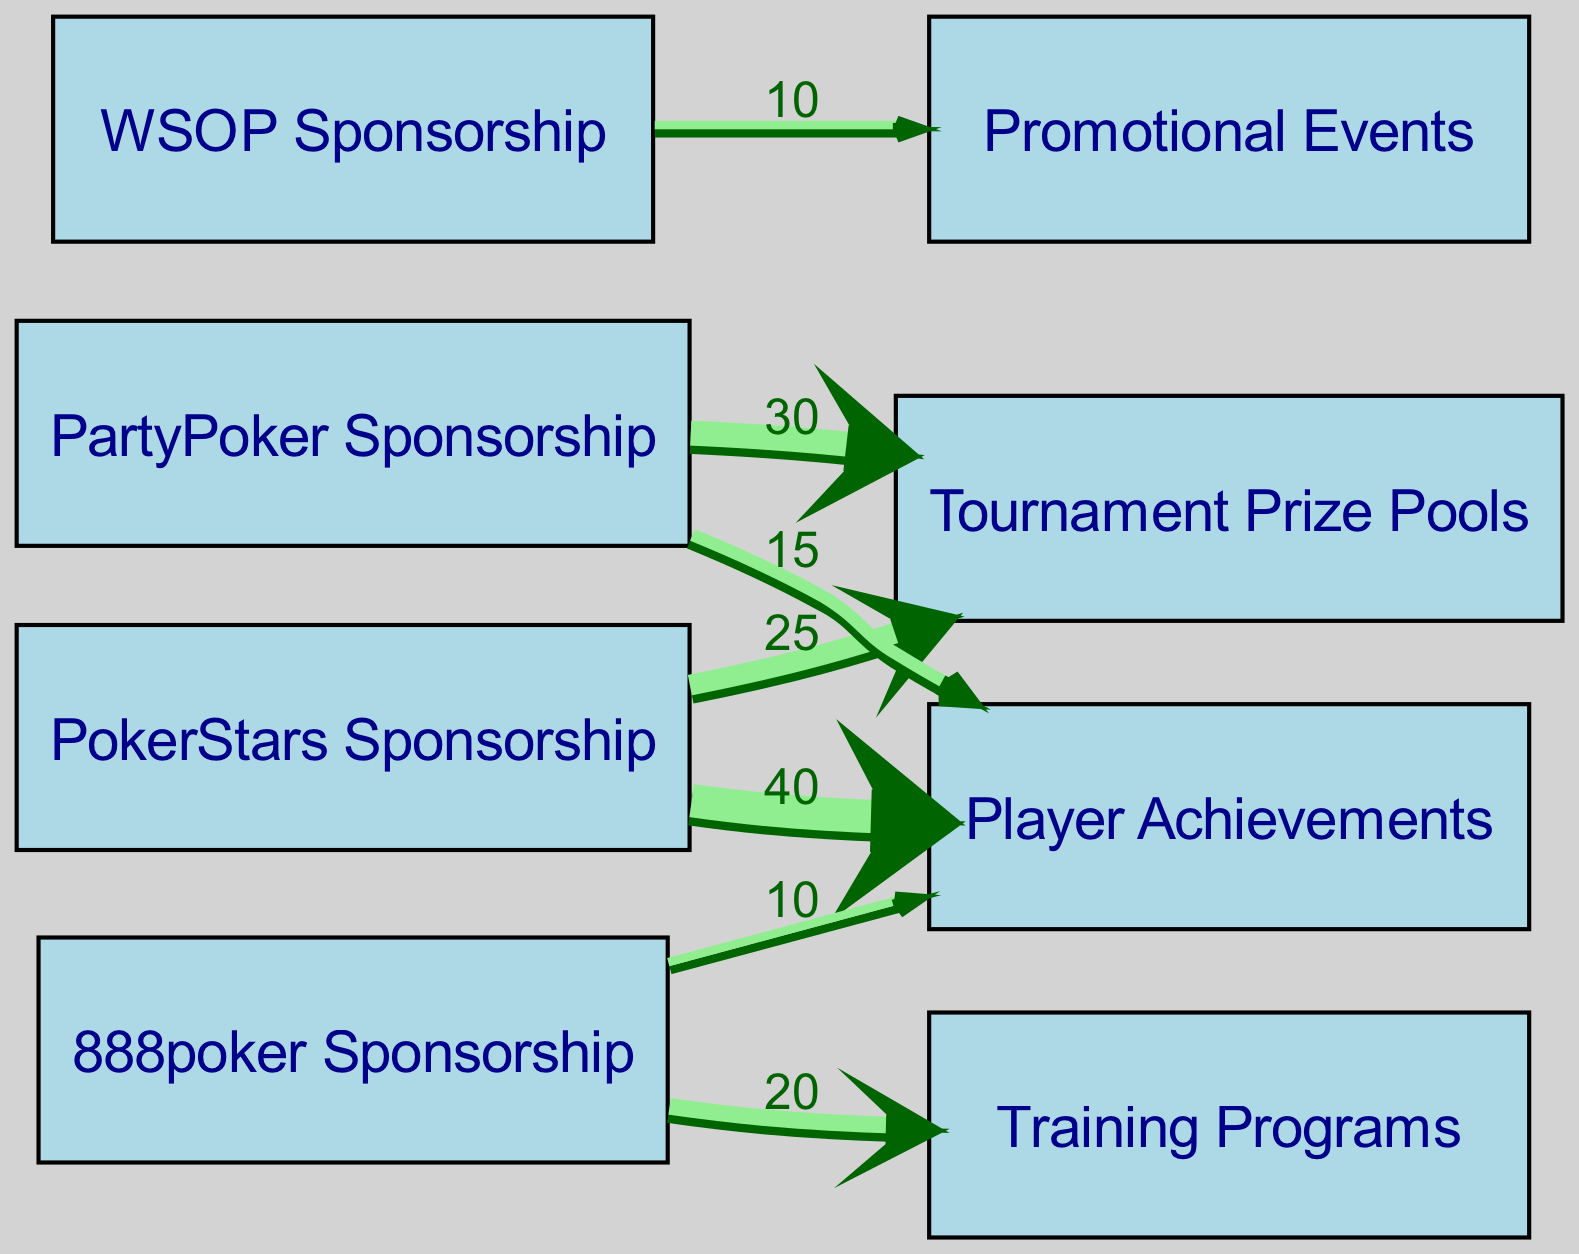What is the total contribution from PokerStars Sponsorship? The total contribution from PokerStars Sponsorship can be calculated by summing the values of its outgoing links. It contributes 40 to Player Achievements and 25 to Tournament Prize Pools. So, 40 + 25 = 65.
Answer: 65 Which sponsorship contributes the most to Player Achievements? To identify the sponsorship contributing the most to Player Achievements, we look at the links directed to this node. PokerStars contributes 40 and PartyPoker contributes 15. The higher value is 40 from PokerStars.
Answer: PokerStars Sponsorship How many nodes are present in the diagram? To find the number of nodes, we simply count all unique entities in the 'nodes' section. There are 8 nodes listed.
Answer: 8 What is the value of contributions from 888poker Sponsorship to Training Programs? The link for 888poker Sponsorship to Training Programs has a value specified, which is 20. This directly answers the question.
Answer: 20 Which sponsorship has the least contribution overall? To determine which sponsorship has the least overall contribution, we must sum the contributions from each sponsorship. WSOP contributes only 10 to Promotional Events and has no additional contributions. Hence, it has the least total contribution.
Answer: WSOP Sponsorship What is the total contribution to Tournament Prize Pools from both PartyPoker and PokerStars Sponsorship? The total contribution to Tournament Prize Pools from both sponsors can be found by adding the contributions from each. PartyPoker contributes 30 and PokerStars contributes 25, totaling 30 + 25 = 55.
Answer: 55 Which sponsorship has a link to Promotional Events? From the diagram’s links, the only sponsorship that connects to Promotional Events is WSOP Sponsorship, which has a contribution value of 10.
Answer: WSOP Sponsorship How many contributions are directed to Player Achievements in total? To find the total contributions directed to Player Achievements, we add the contributions from PokerStars (40) and PartyPoker (15), and also 888poker (10). Therefore, the total is 40 + 15 + 10 = 65.
Answer: 65 